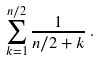<formula> <loc_0><loc_0><loc_500><loc_500>\sum _ { k = 1 } ^ { n / 2 } \frac { 1 } { { n / 2 } + k } \, .</formula> 